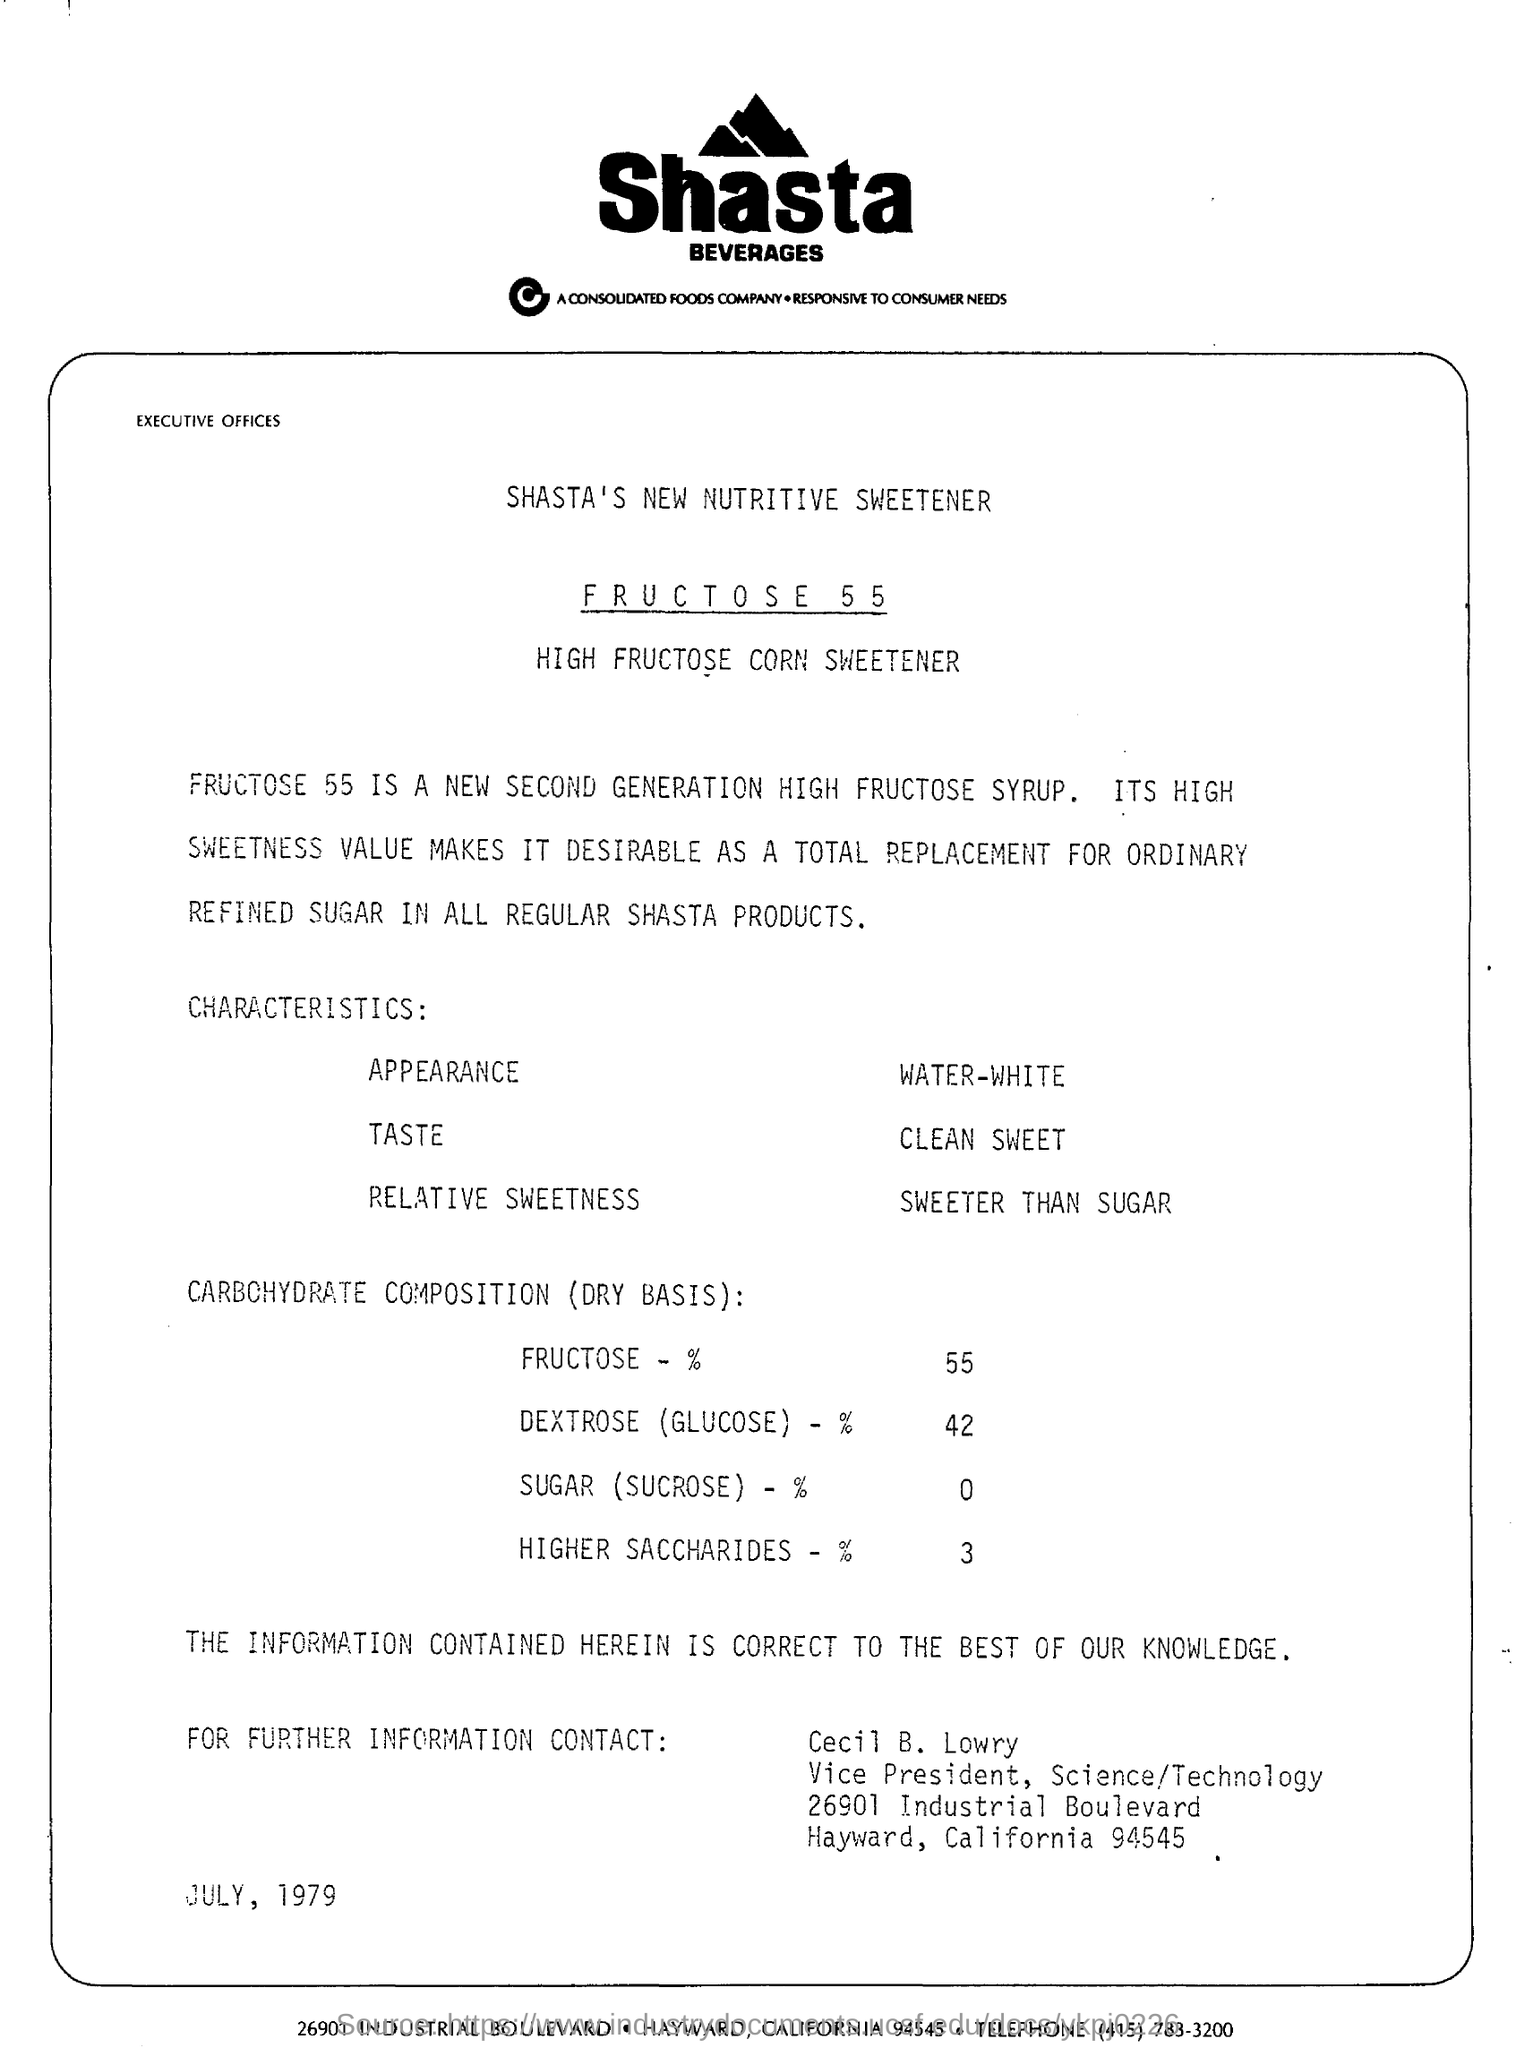What is the name of the beverages company?
Your answer should be compact. Shasta beverages. Which is the new second generation high fructose syrup?
Your response must be concise. F R U C T O S E  5 5. What is the date mentioned?
Offer a terse response. JULY, 1979. What is the DEXTROSE (GLUCOSE) level?
Make the answer very short. 42. 